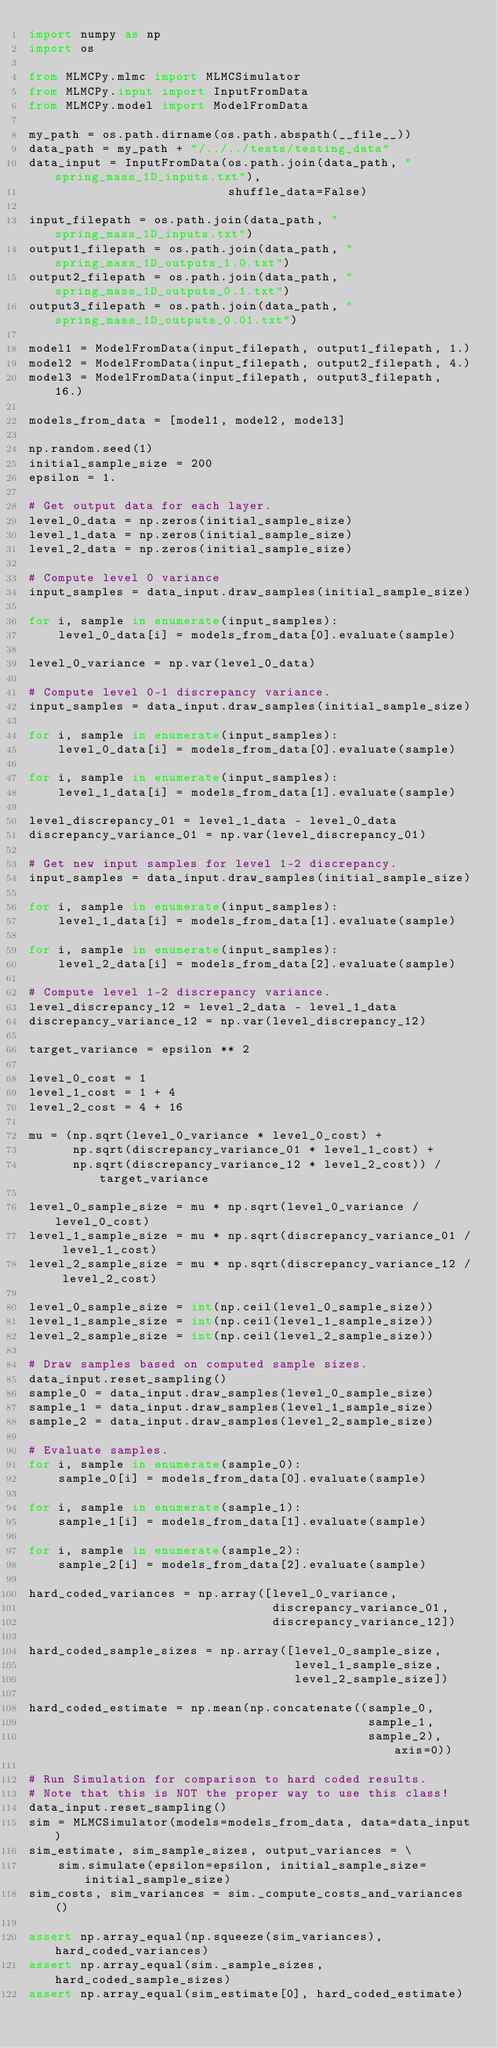Convert code to text. <code><loc_0><loc_0><loc_500><loc_500><_Python_>import numpy as np
import os

from MLMCPy.mlmc import MLMCSimulator
from MLMCPy.input import InputFromData
from MLMCPy.model import ModelFromData

my_path = os.path.dirname(os.path.abspath(__file__))
data_path = my_path + "/../../tests/testing_data"
data_input = InputFromData(os.path.join(data_path, "spring_mass_1D_inputs.txt"),
                           shuffle_data=False)

input_filepath = os.path.join(data_path, "spring_mass_1D_inputs.txt")
output1_filepath = os.path.join(data_path, "spring_mass_1D_outputs_1.0.txt")
output2_filepath = os.path.join(data_path, "spring_mass_1D_outputs_0.1.txt")
output3_filepath = os.path.join(data_path, "spring_mass_1D_outputs_0.01.txt")

model1 = ModelFromData(input_filepath, output1_filepath, 1.)
model2 = ModelFromData(input_filepath, output2_filepath, 4.)
model3 = ModelFromData(input_filepath, output3_filepath, 16.)

models_from_data = [model1, model2, model3]

np.random.seed(1)
initial_sample_size = 200
epsilon = 1.

# Get output data for each layer.
level_0_data = np.zeros(initial_sample_size)
level_1_data = np.zeros(initial_sample_size)
level_2_data = np.zeros(initial_sample_size)

# Compute level 0 variance
input_samples = data_input.draw_samples(initial_sample_size)

for i, sample in enumerate(input_samples):
    level_0_data[i] = models_from_data[0].evaluate(sample)

level_0_variance = np.var(level_0_data)

# Compute level 0-1 discrepancy variance.
input_samples = data_input.draw_samples(initial_sample_size)

for i, sample in enumerate(input_samples):
    level_0_data[i] = models_from_data[0].evaluate(sample)

for i, sample in enumerate(input_samples):
    level_1_data[i] = models_from_data[1].evaluate(sample)

level_discrepancy_01 = level_1_data - level_0_data
discrepancy_variance_01 = np.var(level_discrepancy_01)

# Get new input samples for level 1-2 discrepancy.
input_samples = data_input.draw_samples(initial_sample_size)

for i, sample in enumerate(input_samples):
    level_1_data[i] = models_from_data[1].evaluate(sample)

for i, sample in enumerate(input_samples):
    level_2_data[i] = models_from_data[2].evaluate(sample)

# Compute level 1-2 discrepancy variance.
level_discrepancy_12 = level_2_data - level_1_data
discrepancy_variance_12 = np.var(level_discrepancy_12)

target_variance = epsilon ** 2

level_0_cost = 1
level_1_cost = 1 + 4
level_2_cost = 4 + 16

mu = (np.sqrt(level_0_variance * level_0_cost) +
      np.sqrt(discrepancy_variance_01 * level_1_cost) +
      np.sqrt(discrepancy_variance_12 * level_2_cost)) / target_variance

level_0_sample_size = mu * np.sqrt(level_0_variance / level_0_cost)
level_1_sample_size = mu * np.sqrt(discrepancy_variance_01 / level_1_cost)
level_2_sample_size = mu * np.sqrt(discrepancy_variance_12 / level_2_cost)

level_0_sample_size = int(np.ceil(level_0_sample_size))
level_1_sample_size = int(np.ceil(level_1_sample_size))
level_2_sample_size = int(np.ceil(level_2_sample_size))

# Draw samples based on computed sample sizes.
data_input.reset_sampling()
sample_0 = data_input.draw_samples(level_0_sample_size)
sample_1 = data_input.draw_samples(level_1_sample_size)
sample_2 = data_input.draw_samples(level_2_sample_size)

# Evaluate samples.
for i, sample in enumerate(sample_0):
    sample_0[i] = models_from_data[0].evaluate(sample)

for i, sample in enumerate(sample_1):
    sample_1[i] = models_from_data[1].evaluate(sample)

for i, sample in enumerate(sample_2):
    sample_2[i] = models_from_data[2].evaluate(sample)

hard_coded_variances = np.array([level_0_variance,
                                 discrepancy_variance_01,
                                 discrepancy_variance_12])

hard_coded_sample_sizes = np.array([level_0_sample_size,
                                    level_1_sample_size,
                                    level_2_sample_size])

hard_coded_estimate = np.mean(np.concatenate((sample_0,
                                              sample_1,
                                              sample_2), axis=0))

# Run Simulation for comparison to hard coded results.
# Note that this is NOT the proper way to use this class!
data_input.reset_sampling()
sim = MLMCSimulator(models=models_from_data, data=data_input)
sim_estimate, sim_sample_sizes, output_variances = \
    sim.simulate(epsilon=epsilon, initial_sample_size=initial_sample_size)
sim_costs, sim_variances = sim._compute_costs_and_variances()

assert np.array_equal(np.squeeze(sim_variances), hard_coded_variances)
assert np.array_equal(sim._sample_sizes, hard_coded_sample_sizes)
assert np.array_equal(sim_estimate[0], hard_coded_estimate)
</code> 